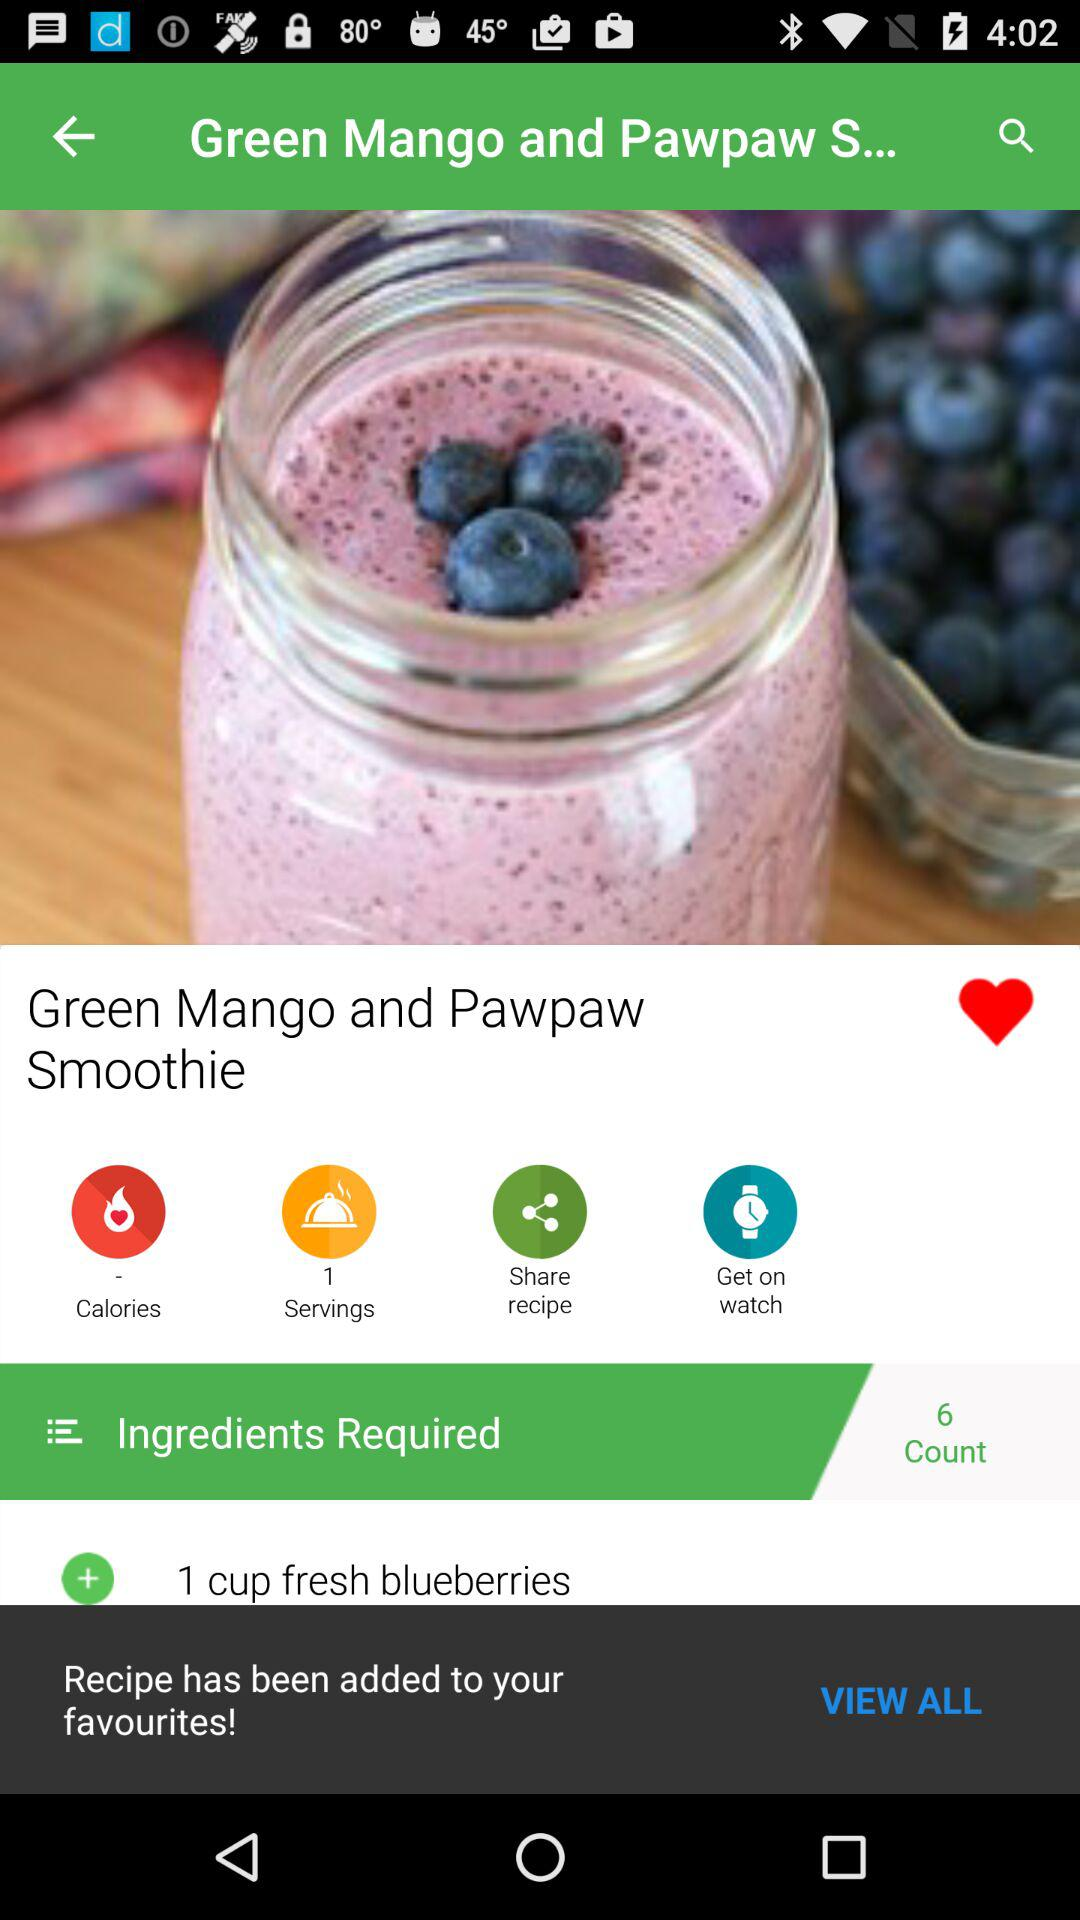How many ingredients are required to make this recipe?
Answer the question using a single word or phrase. 6 